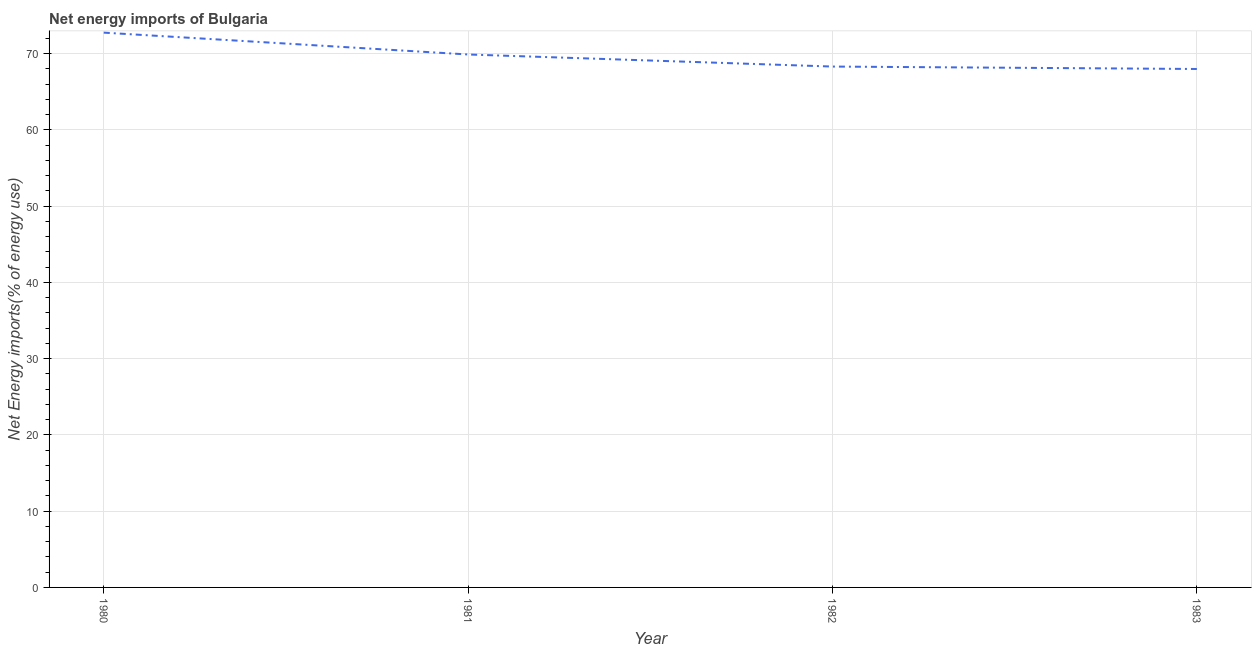What is the energy imports in 1981?
Offer a terse response. 69.88. Across all years, what is the maximum energy imports?
Offer a very short reply. 72.75. Across all years, what is the minimum energy imports?
Make the answer very short. 67.98. In which year was the energy imports maximum?
Provide a short and direct response. 1980. What is the sum of the energy imports?
Ensure brevity in your answer.  278.91. What is the difference between the energy imports in 1981 and 1982?
Your answer should be very brief. 1.58. What is the average energy imports per year?
Your response must be concise. 69.73. What is the median energy imports?
Your response must be concise. 69.09. What is the ratio of the energy imports in 1982 to that in 1983?
Provide a succinct answer. 1. What is the difference between the highest and the second highest energy imports?
Make the answer very short. 2.86. What is the difference between the highest and the lowest energy imports?
Ensure brevity in your answer.  4.77. In how many years, is the energy imports greater than the average energy imports taken over all years?
Ensure brevity in your answer.  2. How many years are there in the graph?
Offer a terse response. 4. What is the difference between two consecutive major ticks on the Y-axis?
Offer a terse response. 10. Does the graph contain grids?
Provide a short and direct response. Yes. What is the title of the graph?
Provide a short and direct response. Net energy imports of Bulgaria. What is the label or title of the X-axis?
Give a very brief answer. Year. What is the label or title of the Y-axis?
Your answer should be compact. Net Energy imports(% of energy use). What is the Net Energy imports(% of energy use) in 1980?
Provide a short and direct response. 72.75. What is the Net Energy imports(% of energy use) of 1981?
Provide a succinct answer. 69.88. What is the Net Energy imports(% of energy use) in 1982?
Provide a short and direct response. 68.3. What is the Net Energy imports(% of energy use) in 1983?
Provide a short and direct response. 67.98. What is the difference between the Net Energy imports(% of energy use) in 1980 and 1981?
Provide a short and direct response. 2.86. What is the difference between the Net Energy imports(% of energy use) in 1980 and 1982?
Ensure brevity in your answer.  4.45. What is the difference between the Net Energy imports(% of energy use) in 1980 and 1983?
Your response must be concise. 4.77. What is the difference between the Net Energy imports(% of energy use) in 1981 and 1982?
Give a very brief answer. 1.58. What is the difference between the Net Energy imports(% of energy use) in 1981 and 1983?
Offer a very short reply. 1.9. What is the difference between the Net Energy imports(% of energy use) in 1982 and 1983?
Give a very brief answer. 0.32. What is the ratio of the Net Energy imports(% of energy use) in 1980 to that in 1981?
Offer a very short reply. 1.04. What is the ratio of the Net Energy imports(% of energy use) in 1980 to that in 1982?
Keep it short and to the point. 1.06. What is the ratio of the Net Energy imports(% of energy use) in 1980 to that in 1983?
Provide a short and direct response. 1.07. What is the ratio of the Net Energy imports(% of energy use) in 1981 to that in 1982?
Ensure brevity in your answer.  1.02. What is the ratio of the Net Energy imports(% of energy use) in 1981 to that in 1983?
Give a very brief answer. 1.03. 